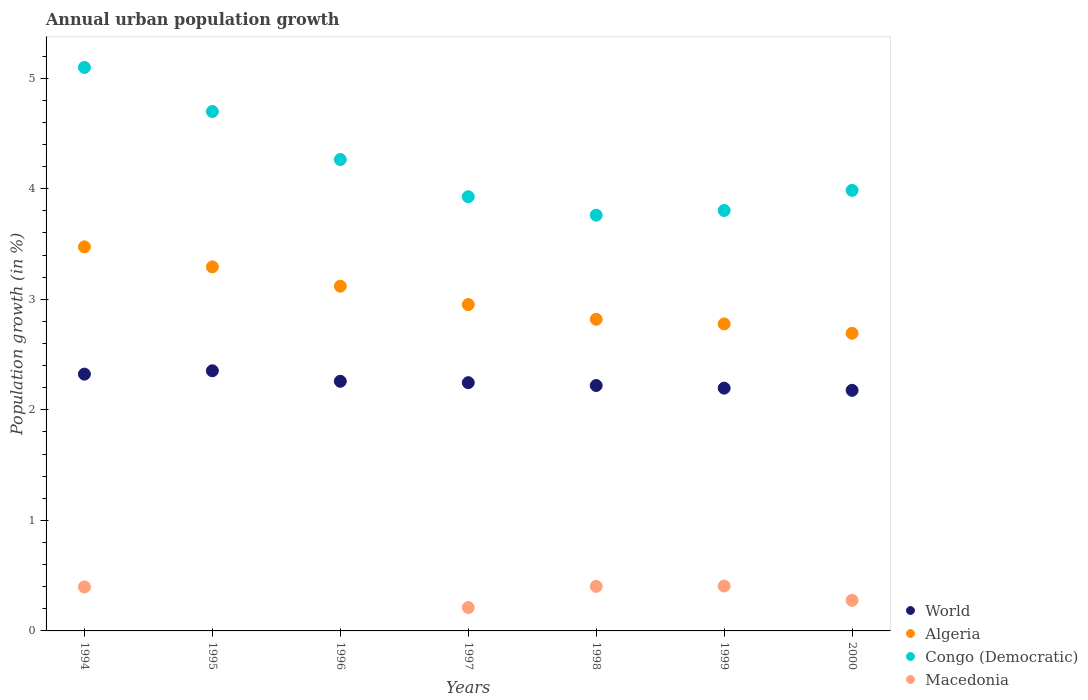How many different coloured dotlines are there?
Ensure brevity in your answer.  4. Is the number of dotlines equal to the number of legend labels?
Keep it short and to the point. No. What is the percentage of urban population growth in Algeria in 1997?
Your response must be concise. 2.95. Across all years, what is the maximum percentage of urban population growth in World?
Your answer should be very brief. 2.35. Across all years, what is the minimum percentage of urban population growth in World?
Ensure brevity in your answer.  2.18. What is the total percentage of urban population growth in Algeria in the graph?
Your answer should be compact. 21.13. What is the difference between the percentage of urban population growth in World in 1997 and that in 1998?
Your answer should be very brief. 0.03. What is the difference between the percentage of urban population growth in World in 1998 and the percentage of urban population growth in Macedonia in 1996?
Your response must be concise. 2.22. What is the average percentage of urban population growth in Congo (Democratic) per year?
Ensure brevity in your answer.  4.22. In the year 1998, what is the difference between the percentage of urban population growth in Congo (Democratic) and percentage of urban population growth in Macedonia?
Offer a very short reply. 3.36. What is the ratio of the percentage of urban population growth in World in 1996 to that in 1997?
Make the answer very short. 1.01. Is the percentage of urban population growth in Algeria in 1996 less than that in 1997?
Your answer should be very brief. No. What is the difference between the highest and the second highest percentage of urban population growth in World?
Offer a terse response. 0.03. What is the difference between the highest and the lowest percentage of urban population growth in Algeria?
Provide a succinct answer. 0.78. Is the sum of the percentage of urban population growth in World in 1996 and 2000 greater than the maximum percentage of urban population growth in Congo (Democratic) across all years?
Make the answer very short. No. Is it the case that in every year, the sum of the percentage of urban population growth in Congo (Democratic) and percentage of urban population growth in Macedonia  is greater than the sum of percentage of urban population growth in World and percentage of urban population growth in Algeria?
Your response must be concise. Yes. How many years are there in the graph?
Offer a terse response. 7. Are the values on the major ticks of Y-axis written in scientific E-notation?
Your answer should be compact. No. What is the title of the graph?
Keep it short and to the point. Annual urban population growth. Does "Rwanda" appear as one of the legend labels in the graph?
Make the answer very short. No. What is the label or title of the Y-axis?
Provide a succinct answer. Population growth (in %). What is the Population growth (in %) of World in 1994?
Make the answer very short. 2.32. What is the Population growth (in %) of Algeria in 1994?
Your answer should be compact. 3.47. What is the Population growth (in %) in Congo (Democratic) in 1994?
Offer a very short reply. 5.1. What is the Population growth (in %) in Macedonia in 1994?
Keep it short and to the point. 0.4. What is the Population growth (in %) of World in 1995?
Offer a very short reply. 2.35. What is the Population growth (in %) of Algeria in 1995?
Offer a terse response. 3.29. What is the Population growth (in %) in Congo (Democratic) in 1995?
Offer a terse response. 4.7. What is the Population growth (in %) of Macedonia in 1995?
Provide a short and direct response. 0. What is the Population growth (in %) in World in 1996?
Provide a succinct answer. 2.26. What is the Population growth (in %) in Algeria in 1996?
Your response must be concise. 3.12. What is the Population growth (in %) of Congo (Democratic) in 1996?
Give a very brief answer. 4.26. What is the Population growth (in %) in World in 1997?
Keep it short and to the point. 2.25. What is the Population growth (in %) in Algeria in 1997?
Make the answer very short. 2.95. What is the Population growth (in %) in Congo (Democratic) in 1997?
Your answer should be very brief. 3.93. What is the Population growth (in %) of Macedonia in 1997?
Offer a very short reply. 0.21. What is the Population growth (in %) in World in 1998?
Ensure brevity in your answer.  2.22. What is the Population growth (in %) in Algeria in 1998?
Keep it short and to the point. 2.82. What is the Population growth (in %) in Congo (Democratic) in 1998?
Offer a very short reply. 3.76. What is the Population growth (in %) of Macedonia in 1998?
Your response must be concise. 0.4. What is the Population growth (in %) in World in 1999?
Keep it short and to the point. 2.2. What is the Population growth (in %) in Algeria in 1999?
Your answer should be very brief. 2.78. What is the Population growth (in %) of Congo (Democratic) in 1999?
Offer a terse response. 3.8. What is the Population growth (in %) of Macedonia in 1999?
Your answer should be compact. 0.41. What is the Population growth (in %) of World in 2000?
Keep it short and to the point. 2.18. What is the Population growth (in %) of Algeria in 2000?
Offer a very short reply. 2.69. What is the Population growth (in %) in Congo (Democratic) in 2000?
Your answer should be very brief. 3.99. What is the Population growth (in %) of Macedonia in 2000?
Make the answer very short. 0.28. Across all years, what is the maximum Population growth (in %) of World?
Keep it short and to the point. 2.35. Across all years, what is the maximum Population growth (in %) in Algeria?
Give a very brief answer. 3.47. Across all years, what is the maximum Population growth (in %) in Congo (Democratic)?
Offer a terse response. 5.1. Across all years, what is the maximum Population growth (in %) of Macedonia?
Offer a terse response. 0.41. Across all years, what is the minimum Population growth (in %) in World?
Provide a succinct answer. 2.18. Across all years, what is the minimum Population growth (in %) in Algeria?
Your answer should be very brief. 2.69. Across all years, what is the minimum Population growth (in %) in Congo (Democratic)?
Make the answer very short. 3.76. Across all years, what is the minimum Population growth (in %) in Macedonia?
Provide a short and direct response. 0. What is the total Population growth (in %) in World in the graph?
Your response must be concise. 15.77. What is the total Population growth (in %) in Algeria in the graph?
Offer a terse response. 21.13. What is the total Population growth (in %) in Congo (Democratic) in the graph?
Keep it short and to the point. 29.54. What is the total Population growth (in %) in Macedonia in the graph?
Your response must be concise. 1.69. What is the difference between the Population growth (in %) in World in 1994 and that in 1995?
Give a very brief answer. -0.03. What is the difference between the Population growth (in %) in Algeria in 1994 and that in 1995?
Your answer should be very brief. 0.18. What is the difference between the Population growth (in %) in Congo (Democratic) in 1994 and that in 1995?
Your answer should be very brief. 0.4. What is the difference between the Population growth (in %) of World in 1994 and that in 1996?
Your answer should be very brief. 0.06. What is the difference between the Population growth (in %) in Algeria in 1994 and that in 1996?
Your response must be concise. 0.36. What is the difference between the Population growth (in %) of Congo (Democratic) in 1994 and that in 1996?
Keep it short and to the point. 0.83. What is the difference between the Population growth (in %) in World in 1994 and that in 1997?
Your answer should be compact. 0.08. What is the difference between the Population growth (in %) in Algeria in 1994 and that in 1997?
Make the answer very short. 0.52. What is the difference between the Population growth (in %) in Congo (Democratic) in 1994 and that in 1997?
Your response must be concise. 1.17. What is the difference between the Population growth (in %) in Macedonia in 1994 and that in 1997?
Make the answer very short. 0.19. What is the difference between the Population growth (in %) of World in 1994 and that in 1998?
Offer a terse response. 0.1. What is the difference between the Population growth (in %) of Algeria in 1994 and that in 1998?
Your answer should be compact. 0.66. What is the difference between the Population growth (in %) in Congo (Democratic) in 1994 and that in 1998?
Offer a very short reply. 1.34. What is the difference between the Population growth (in %) of Macedonia in 1994 and that in 1998?
Keep it short and to the point. -0.01. What is the difference between the Population growth (in %) of World in 1994 and that in 1999?
Make the answer very short. 0.13. What is the difference between the Population growth (in %) in Algeria in 1994 and that in 1999?
Provide a succinct answer. 0.7. What is the difference between the Population growth (in %) of Congo (Democratic) in 1994 and that in 1999?
Your response must be concise. 1.29. What is the difference between the Population growth (in %) in Macedonia in 1994 and that in 1999?
Your response must be concise. -0.01. What is the difference between the Population growth (in %) in World in 1994 and that in 2000?
Offer a terse response. 0.15. What is the difference between the Population growth (in %) in Algeria in 1994 and that in 2000?
Provide a succinct answer. 0.78. What is the difference between the Population growth (in %) in Congo (Democratic) in 1994 and that in 2000?
Your answer should be compact. 1.11. What is the difference between the Population growth (in %) of Macedonia in 1994 and that in 2000?
Offer a very short reply. 0.12. What is the difference between the Population growth (in %) in World in 1995 and that in 1996?
Offer a very short reply. 0.09. What is the difference between the Population growth (in %) of Algeria in 1995 and that in 1996?
Offer a very short reply. 0.17. What is the difference between the Population growth (in %) of Congo (Democratic) in 1995 and that in 1996?
Make the answer very short. 0.43. What is the difference between the Population growth (in %) in World in 1995 and that in 1997?
Provide a short and direct response. 0.11. What is the difference between the Population growth (in %) of Algeria in 1995 and that in 1997?
Offer a terse response. 0.34. What is the difference between the Population growth (in %) in Congo (Democratic) in 1995 and that in 1997?
Provide a succinct answer. 0.77. What is the difference between the Population growth (in %) in World in 1995 and that in 1998?
Keep it short and to the point. 0.13. What is the difference between the Population growth (in %) of Algeria in 1995 and that in 1998?
Your answer should be compact. 0.47. What is the difference between the Population growth (in %) of Congo (Democratic) in 1995 and that in 1998?
Keep it short and to the point. 0.94. What is the difference between the Population growth (in %) of World in 1995 and that in 1999?
Provide a short and direct response. 0.16. What is the difference between the Population growth (in %) in Algeria in 1995 and that in 1999?
Your answer should be compact. 0.52. What is the difference between the Population growth (in %) of Congo (Democratic) in 1995 and that in 1999?
Make the answer very short. 0.9. What is the difference between the Population growth (in %) in World in 1995 and that in 2000?
Make the answer very short. 0.18. What is the difference between the Population growth (in %) of Algeria in 1995 and that in 2000?
Make the answer very short. 0.6. What is the difference between the Population growth (in %) in Congo (Democratic) in 1995 and that in 2000?
Your answer should be compact. 0.71. What is the difference between the Population growth (in %) in World in 1996 and that in 1997?
Make the answer very short. 0.01. What is the difference between the Population growth (in %) of Algeria in 1996 and that in 1997?
Offer a terse response. 0.17. What is the difference between the Population growth (in %) of Congo (Democratic) in 1996 and that in 1997?
Your answer should be very brief. 0.34. What is the difference between the Population growth (in %) of World in 1996 and that in 1998?
Make the answer very short. 0.04. What is the difference between the Population growth (in %) in Algeria in 1996 and that in 1998?
Keep it short and to the point. 0.3. What is the difference between the Population growth (in %) in Congo (Democratic) in 1996 and that in 1998?
Your answer should be very brief. 0.5. What is the difference between the Population growth (in %) of World in 1996 and that in 1999?
Ensure brevity in your answer.  0.06. What is the difference between the Population growth (in %) of Algeria in 1996 and that in 1999?
Your answer should be very brief. 0.34. What is the difference between the Population growth (in %) in Congo (Democratic) in 1996 and that in 1999?
Keep it short and to the point. 0.46. What is the difference between the Population growth (in %) of World in 1996 and that in 2000?
Make the answer very short. 0.08. What is the difference between the Population growth (in %) of Algeria in 1996 and that in 2000?
Give a very brief answer. 0.43. What is the difference between the Population growth (in %) in Congo (Democratic) in 1996 and that in 2000?
Offer a terse response. 0.28. What is the difference between the Population growth (in %) of World in 1997 and that in 1998?
Offer a very short reply. 0.03. What is the difference between the Population growth (in %) of Algeria in 1997 and that in 1998?
Ensure brevity in your answer.  0.13. What is the difference between the Population growth (in %) of Congo (Democratic) in 1997 and that in 1998?
Keep it short and to the point. 0.17. What is the difference between the Population growth (in %) in Macedonia in 1997 and that in 1998?
Give a very brief answer. -0.19. What is the difference between the Population growth (in %) in World in 1997 and that in 1999?
Keep it short and to the point. 0.05. What is the difference between the Population growth (in %) of Algeria in 1997 and that in 1999?
Keep it short and to the point. 0.17. What is the difference between the Population growth (in %) of Congo (Democratic) in 1997 and that in 1999?
Offer a terse response. 0.12. What is the difference between the Population growth (in %) in Macedonia in 1997 and that in 1999?
Your answer should be compact. -0.19. What is the difference between the Population growth (in %) in World in 1997 and that in 2000?
Keep it short and to the point. 0.07. What is the difference between the Population growth (in %) of Algeria in 1997 and that in 2000?
Make the answer very short. 0.26. What is the difference between the Population growth (in %) of Congo (Democratic) in 1997 and that in 2000?
Your response must be concise. -0.06. What is the difference between the Population growth (in %) of Macedonia in 1997 and that in 2000?
Your response must be concise. -0.06. What is the difference between the Population growth (in %) in World in 1998 and that in 1999?
Your response must be concise. 0.02. What is the difference between the Population growth (in %) of Algeria in 1998 and that in 1999?
Ensure brevity in your answer.  0.04. What is the difference between the Population growth (in %) of Congo (Democratic) in 1998 and that in 1999?
Give a very brief answer. -0.04. What is the difference between the Population growth (in %) of Macedonia in 1998 and that in 1999?
Offer a very short reply. -0. What is the difference between the Population growth (in %) of World in 1998 and that in 2000?
Give a very brief answer. 0.04. What is the difference between the Population growth (in %) of Algeria in 1998 and that in 2000?
Provide a short and direct response. 0.13. What is the difference between the Population growth (in %) in Congo (Democratic) in 1998 and that in 2000?
Your answer should be compact. -0.22. What is the difference between the Population growth (in %) in Macedonia in 1998 and that in 2000?
Your answer should be very brief. 0.13. What is the difference between the Population growth (in %) of World in 1999 and that in 2000?
Provide a succinct answer. 0.02. What is the difference between the Population growth (in %) of Algeria in 1999 and that in 2000?
Your answer should be very brief. 0.09. What is the difference between the Population growth (in %) in Congo (Democratic) in 1999 and that in 2000?
Provide a succinct answer. -0.18. What is the difference between the Population growth (in %) of Macedonia in 1999 and that in 2000?
Offer a terse response. 0.13. What is the difference between the Population growth (in %) in World in 1994 and the Population growth (in %) in Algeria in 1995?
Provide a short and direct response. -0.97. What is the difference between the Population growth (in %) of World in 1994 and the Population growth (in %) of Congo (Democratic) in 1995?
Your answer should be compact. -2.38. What is the difference between the Population growth (in %) of Algeria in 1994 and the Population growth (in %) of Congo (Democratic) in 1995?
Your answer should be compact. -1.22. What is the difference between the Population growth (in %) in World in 1994 and the Population growth (in %) in Algeria in 1996?
Your answer should be compact. -0.8. What is the difference between the Population growth (in %) in World in 1994 and the Population growth (in %) in Congo (Democratic) in 1996?
Your answer should be compact. -1.94. What is the difference between the Population growth (in %) of Algeria in 1994 and the Population growth (in %) of Congo (Democratic) in 1996?
Offer a terse response. -0.79. What is the difference between the Population growth (in %) in World in 1994 and the Population growth (in %) in Algeria in 1997?
Ensure brevity in your answer.  -0.63. What is the difference between the Population growth (in %) of World in 1994 and the Population growth (in %) of Congo (Democratic) in 1997?
Provide a succinct answer. -1.6. What is the difference between the Population growth (in %) of World in 1994 and the Population growth (in %) of Macedonia in 1997?
Your answer should be very brief. 2.11. What is the difference between the Population growth (in %) of Algeria in 1994 and the Population growth (in %) of Congo (Democratic) in 1997?
Provide a short and direct response. -0.45. What is the difference between the Population growth (in %) of Algeria in 1994 and the Population growth (in %) of Macedonia in 1997?
Offer a very short reply. 3.26. What is the difference between the Population growth (in %) in Congo (Democratic) in 1994 and the Population growth (in %) in Macedonia in 1997?
Your answer should be very brief. 4.89. What is the difference between the Population growth (in %) in World in 1994 and the Population growth (in %) in Algeria in 1998?
Provide a short and direct response. -0.5. What is the difference between the Population growth (in %) of World in 1994 and the Population growth (in %) of Congo (Democratic) in 1998?
Your answer should be compact. -1.44. What is the difference between the Population growth (in %) in World in 1994 and the Population growth (in %) in Macedonia in 1998?
Give a very brief answer. 1.92. What is the difference between the Population growth (in %) in Algeria in 1994 and the Population growth (in %) in Congo (Democratic) in 1998?
Provide a succinct answer. -0.29. What is the difference between the Population growth (in %) in Algeria in 1994 and the Population growth (in %) in Macedonia in 1998?
Your answer should be compact. 3.07. What is the difference between the Population growth (in %) in Congo (Democratic) in 1994 and the Population growth (in %) in Macedonia in 1998?
Ensure brevity in your answer.  4.69. What is the difference between the Population growth (in %) in World in 1994 and the Population growth (in %) in Algeria in 1999?
Keep it short and to the point. -0.45. What is the difference between the Population growth (in %) in World in 1994 and the Population growth (in %) in Congo (Democratic) in 1999?
Your response must be concise. -1.48. What is the difference between the Population growth (in %) in World in 1994 and the Population growth (in %) in Macedonia in 1999?
Offer a very short reply. 1.92. What is the difference between the Population growth (in %) in Algeria in 1994 and the Population growth (in %) in Congo (Democratic) in 1999?
Your answer should be very brief. -0.33. What is the difference between the Population growth (in %) of Algeria in 1994 and the Population growth (in %) of Macedonia in 1999?
Offer a terse response. 3.07. What is the difference between the Population growth (in %) in Congo (Democratic) in 1994 and the Population growth (in %) in Macedonia in 1999?
Give a very brief answer. 4.69. What is the difference between the Population growth (in %) of World in 1994 and the Population growth (in %) of Algeria in 2000?
Your answer should be compact. -0.37. What is the difference between the Population growth (in %) in World in 1994 and the Population growth (in %) in Congo (Democratic) in 2000?
Offer a very short reply. -1.66. What is the difference between the Population growth (in %) of World in 1994 and the Population growth (in %) of Macedonia in 2000?
Your answer should be compact. 2.05. What is the difference between the Population growth (in %) in Algeria in 1994 and the Population growth (in %) in Congo (Democratic) in 2000?
Offer a very short reply. -0.51. What is the difference between the Population growth (in %) in Algeria in 1994 and the Population growth (in %) in Macedonia in 2000?
Your response must be concise. 3.2. What is the difference between the Population growth (in %) in Congo (Democratic) in 1994 and the Population growth (in %) in Macedonia in 2000?
Ensure brevity in your answer.  4.82. What is the difference between the Population growth (in %) of World in 1995 and the Population growth (in %) of Algeria in 1996?
Make the answer very short. -0.77. What is the difference between the Population growth (in %) in World in 1995 and the Population growth (in %) in Congo (Democratic) in 1996?
Offer a terse response. -1.91. What is the difference between the Population growth (in %) of Algeria in 1995 and the Population growth (in %) of Congo (Democratic) in 1996?
Provide a succinct answer. -0.97. What is the difference between the Population growth (in %) of World in 1995 and the Population growth (in %) of Algeria in 1997?
Offer a terse response. -0.6. What is the difference between the Population growth (in %) in World in 1995 and the Population growth (in %) in Congo (Democratic) in 1997?
Provide a short and direct response. -1.57. What is the difference between the Population growth (in %) of World in 1995 and the Population growth (in %) of Macedonia in 1997?
Provide a short and direct response. 2.14. What is the difference between the Population growth (in %) in Algeria in 1995 and the Population growth (in %) in Congo (Democratic) in 1997?
Give a very brief answer. -0.64. What is the difference between the Population growth (in %) of Algeria in 1995 and the Population growth (in %) of Macedonia in 1997?
Provide a succinct answer. 3.08. What is the difference between the Population growth (in %) in Congo (Democratic) in 1995 and the Population growth (in %) in Macedonia in 1997?
Your answer should be compact. 4.49. What is the difference between the Population growth (in %) of World in 1995 and the Population growth (in %) of Algeria in 1998?
Your response must be concise. -0.47. What is the difference between the Population growth (in %) in World in 1995 and the Population growth (in %) in Congo (Democratic) in 1998?
Your response must be concise. -1.41. What is the difference between the Population growth (in %) of World in 1995 and the Population growth (in %) of Macedonia in 1998?
Your answer should be very brief. 1.95. What is the difference between the Population growth (in %) of Algeria in 1995 and the Population growth (in %) of Congo (Democratic) in 1998?
Ensure brevity in your answer.  -0.47. What is the difference between the Population growth (in %) of Algeria in 1995 and the Population growth (in %) of Macedonia in 1998?
Make the answer very short. 2.89. What is the difference between the Population growth (in %) in Congo (Democratic) in 1995 and the Population growth (in %) in Macedonia in 1998?
Your answer should be very brief. 4.3. What is the difference between the Population growth (in %) of World in 1995 and the Population growth (in %) of Algeria in 1999?
Offer a very short reply. -0.42. What is the difference between the Population growth (in %) of World in 1995 and the Population growth (in %) of Congo (Democratic) in 1999?
Keep it short and to the point. -1.45. What is the difference between the Population growth (in %) of World in 1995 and the Population growth (in %) of Macedonia in 1999?
Ensure brevity in your answer.  1.95. What is the difference between the Population growth (in %) in Algeria in 1995 and the Population growth (in %) in Congo (Democratic) in 1999?
Offer a very short reply. -0.51. What is the difference between the Population growth (in %) of Algeria in 1995 and the Population growth (in %) of Macedonia in 1999?
Offer a terse response. 2.89. What is the difference between the Population growth (in %) in Congo (Democratic) in 1995 and the Population growth (in %) in Macedonia in 1999?
Provide a short and direct response. 4.29. What is the difference between the Population growth (in %) in World in 1995 and the Population growth (in %) in Algeria in 2000?
Ensure brevity in your answer.  -0.34. What is the difference between the Population growth (in %) of World in 1995 and the Population growth (in %) of Congo (Democratic) in 2000?
Your response must be concise. -1.63. What is the difference between the Population growth (in %) in World in 1995 and the Population growth (in %) in Macedonia in 2000?
Provide a succinct answer. 2.08. What is the difference between the Population growth (in %) in Algeria in 1995 and the Population growth (in %) in Congo (Democratic) in 2000?
Ensure brevity in your answer.  -0.69. What is the difference between the Population growth (in %) in Algeria in 1995 and the Population growth (in %) in Macedonia in 2000?
Give a very brief answer. 3.02. What is the difference between the Population growth (in %) in Congo (Democratic) in 1995 and the Population growth (in %) in Macedonia in 2000?
Keep it short and to the point. 4.42. What is the difference between the Population growth (in %) of World in 1996 and the Population growth (in %) of Algeria in 1997?
Your response must be concise. -0.69. What is the difference between the Population growth (in %) in World in 1996 and the Population growth (in %) in Congo (Democratic) in 1997?
Your answer should be compact. -1.67. What is the difference between the Population growth (in %) of World in 1996 and the Population growth (in %) of Macedonia in 1997?
Provide a short and direct response. 2.05. What is the difference between the Population growth (in %) in Algeria in 1996 and the Population growth (in %) in Congo (Democratic) in 1997?
Your answer should be compact. -0.81. What is the difference between the Population growth (in %) of Algeria in 1996 and the Population growth (in %) of Macedonia in 1997?
Offer a terse response. 2.91. What is the difference between the Population growth (in %) of Congo (Democratic) in 1996 and the Population growth (in %) of Macedonia in 1997?
Your answer should be very brief. 4.05. What is the difference between the Population growth (in %) of World in 1996 and the Population growth (in %) of Algeria in 1998?
Ensure brevity in your answer.  -0.56. What is the difference between the Population growth (in %) in World in 1996 and the Population growth (in %) in Congo (Democratic) in 1998?
Your response must be concise. -1.5. What is the difference between the Population growth (in %) in World in 1996 and the Population growth (in %) in Macedonia in 1998?
Your response must be concise. 1.86. What is the difference between the Population growth (in %) in Algeria in 1996 and the Population growth (in %) in Congo (Democratic) in 1998?
Ensure brevity in your answer.  -0.64. What is the difference between the Population growth (in %) of Algeria in 1996 and the Population growth (in %) of Macedonia in 1998?
Your answer should be compact. 2.72. What is the difference between the Population growth (in %) of Congo (Democratic) in 1996 and the Population growth (in %) of Macedonia in 1998?
Keep it short and to the point. 3.86. What is the difference between the Population growth (in %) of World in 1996 and the Population growth (in %) of Algeria in 1999?
Your answer should be very brief. -0.52. What is the difference between the Population growth (in %) in World in 1996 and the Population growth (in %) in Congo (Democratic) in 1999?
Offer a terse response. -1.54. What is the difference between the Population growth (in %) in World in 1996 and the Population growth (in %) in Macedonia in 1999?
Your answer should be very brief. 1.85. What is the difference between the Population growth (in %) in Algeria in 1996 and the Population growth (in %) in Congo (Democratic) in 1999?
Your response must be concise. -0.68. What is the difference between the Population growth (in %) in Algeria in 1996 and the Population growth (in %) in Macedonia in 1999?
Your response must be concise. 2.71. What is the difference between the Population growth (in %) in Congo (Democratic) in 1996 and the Population growth (in %) in Macedonia in 1999?
Ensure brevity in your answer.  3.86. What is the difference between the Population growth (in %) of World in 1996 and the Population growth (in %) of Algeria in 2000?
Your response must be concise. -0.43. What is the difference between the Population growth (in %) in World in 1996 and the Population growth (in %) in Congo (Democratic) in 2000?
Your answer should be very brief. -1.73. What is the difference between the Population growth (in %) of World in 1996 and the Population growth (in %) of Macedonia in 2000?
Provide a short and direct response. 1.98. What is the difference between the Population growth (in %) in Algeria in 1996 and the Population growth (in %) in Congo (Democratic) in 2000?
Provide a short and direct response. -0.87. What is the difference between the Population growth (in %) in Algeria in 1996 and the Population growth (in %) in Macedonia in 2000?
Offer a very short reply. 2.84. What is the difference between the Population growth (in %) of Congo (Democratic) in 1996 and the Population growth (in %) of Macedonia in 2000?
Your answer should be very brief. 3.99. What is the difference between the Population growth (in %) of World in 1997 and the Population growth (in %) of Algeria in 1998?
Provide a short and direct response. -0.57. What is the difference between the Population growth (in %) of World in 1997 and the Population growth (in %) of Congo (Democratic) in 1998?
Provide a short and direct response. -1.52. What is the difference between the Population growth (in %) in World in 1997 and the Population growth (in %) in Macedonia in 1998?
Your answer should be compact. 1.84. What is the difference between the Population growth (in %) in Algeria in 1997 and the Population growth (in %) in Congo (Democratic) in 1998?
Keep it short and to the point. -0.81. What is the difference between the Population growth (in %) in Algeria in 1997 and the Population growth (in %) in Macedonia in 1998?
Provide a short and direct response. 2.55. What is the difference between the Population growth (in %) of Congo (Democratic) in 1997 and the Population growth (in %) of Macedonia in 1998?
Provide a succinct answer. 3.52. What is the difference between the Population growth (in %) in World in 1997 and the Population growth (in %) in Algeria in 1999?
Provide a short and direct response. -0.53. What is the difference between the Population growth (in %) of World in 1997 and the Population growth (in %) of Congo (Democratic) in 1999?
Offer a very short reply. -1.56. What is the difference between the Population growth (in %) of World in 1997 and the Population growth (in %) of Macedonia in 1999?
Offer a very short reply. 1.84. What is the difference between the Population growth (in %) in Algeria in 1997 and the Population growth (in %) in Congo (Democratic) in 1999?
Keep it short and to the point. -0.85. What is the difference between the Population growth (in %) in Algeria in 1997 and the Population growth (in %) in Macedonia in 1999?
Offer a very short reply. 2.55. What is the difference between the Population growth (in %) of Congo (Democratic) in 1997 and the Population growth (in %) of Macedonia in 1999?
Your response must be concise. 3.52. What is the difference between the Population growth (in %) of World in 1997 and the Population growth (in %) of Algeria in 2000?
Provide a short and direct response. -0.45. What is the difference between the Population growth (in %) of World in 1997 and the Population growth (in %) of Congo (Democratic) in 2000?
Give a very brief answer. -1.74. What is the difference between the Population growth (in %) of World in 1997 and the Population growth (in %) of Macedonia in 2000?
Keep it short and to the point. 1.97. What is the difference between the Population growth (in %) of Algeria in 1997 and the Population growth (in %) of Congo (Democratic) in 2000?
Give a very brief answer. -1.03. What is the difference between the Population growth (in %) in Algeria in 1997 and the Population growth (in %) in Macedonia in 2000?
Give a very brief answer. 2.68. What is the difference between the Population growth (in %) in Congo (Democratic) in 1997 and the Population growth (in %) in Macedonia in 2000?
Your response must be concise. 3.65. What is the difference between the Population growth (in %) of World in 1998 and the Population growth (in %) of Algeria in 1999?
Ensure brevity in your answer.  -0.56. What is the difference between the Population growth (in %) of World in 1998 and the Population growth (in %) of Congo (Democratic) in 1999?
Offer a very short reply. -1.58. What is the difference between the Population growth (in %) of World in 1998 and the Population growth (in %) of Macedonia in 1999?
Your answer should be very brief. 1.81. What is the difference between the Population growth (in %) of Algeria in 1998 and the Population growth (in %) of Congo (Democratic) in 1999?
Keep it short and to the point. -0.98. What is the difference between the Population growth (in %) of Algeria in 1998 and the Population growth (in %) of Macedonia in 1999?
Ensure brevity in your answer.  2.41. What is the difference between the Population growth (in %) in Congo (Democratic) in 1998 and the Population growth (in %) in Macedonia in 1999?
Provide a short and direct response. 3.36. What is the difference between the Population growth (in %) of World in 1998 and the Population growth (in %) of Algeria in 2000?
Your response must be concise. -0.47. What is the difference between the Population growth (in %) of World in 1998 and the Population growth (in %) of Congo (Democratic) in 2000?
Ensure brevity in your answer.  -1.77. What is the difference between the Population growth (in %) of World in 1998 and the Population growth (in %) of Macedonia in 2000?
Your answer should be very brief. 1.94. What is the difference between the Population growth (in %) in Algeria in 1998 and the Population growth (in %) in Congo (Democratic) in 2000?
Make the answer very short. -1.17. What is the difference between the Population growth (in %) in Algeria in 1998 and the Population growth (in %) in Macedonia in 2000?
Your response must be concise. 2.54. What is the difference between the Population growth (in %) of Congo (Democratic) in 1998 and the Population growth (in %) of Macedonia in 2000?
Provide a short and direct response. 3.48. What is the difference between the Population growth (in %) of World in 1999 and the Population growth (in %) of Algeria in 2000?
Ensure brevity in your answer.  -0.5. What is the difference between the Population growth (in %) in World in 1999 and the Population growth (in %) in Congo (Democratic) in 2000?
Offer a very short reply. -1.79. What is the difference between the Population growth (in %) in World in 1999 and the Population growth (in %) in Macedonia in 2000?
Provide a short and direct response. 1.92. What is the difference between the Population growth (in %) of Algeria in 1999 and the Population growth (in %) of Congo (Democratic) in 2000?
Provide a succinct answer. -1.21. What is the difference between the Population growth (in %) in Algeria in 1999 and the Population growth (in %) in Macedonia in 2000?
Give a very brief answer. 2.5. What is the difference between the Population growth (in %) in Congo (Democratic) in 1999 and the Population growth (in %) in Macedonia in 2000?
Offer a terse response. 3.53. What is the average Population growth (in %) in World per year?
Ensure brevity in your answer.  2.25. What is the average Population growth (in %) in Algeria per year?
Provide a short and direct response. 3.02. What is the average Population growth (in %) of Congo (Democratic) per year?
Offer a terse response. 4.22. What is the average Population growth (in %) in Macedonia per year?
Give a very brief answer. 0.24. In the year 1994, what is the difference between the Population growth (in %) of World and Population growth (in %) of Algeria?
Your answer should be very brief. -1.15. In the year 1994, what is the difference between the Population growth (in %) in World and Population growth (in %) in Congo (Democratic)?
Provide a succinct answer. -2.77. In the year 1994, what is the difference between the Population growth (in %) of World and Population growth (in %) of Macedonia?
Keep it short and to the point. 1.93. In the year 1994, what is the difference between the Population growth (in %) in Algeria and Population growth (in %) in Congo (Democratic)?
Make the answer very short. -1.62. In the year 1994, what is the difference between the Population growth (in %) of Algeria and Population growth (in %) of Macedonia?
Give a very brief answer. 3.08. In the year 1994, what is the difference between the Population growth (in %) of Congo (Democratic) and Population growth (in %) of Macedonia?
Your answer should be very brief. 4.7. In the year 1995, what is the difference between the Population growth (in %) in World and Population growth (in %) in Algeria?
Your answer should be very brief. -0.94. In the year 1995, what is the difference between the Population growth (in %) of World and Population growth (in %) of Congo (Democratic)?
Your answer should be compact. -2.35. In the year 1995, what is the difference between the Population growth (in %) in Algeria and Population growth (in %) in Congo (Democratic)?
Give a very brief answer. -1.41. In the year 1996, what is the difference between the Population growth (in %) in World and Population growth (in %) in Algeria?
Your answer should be compact. -0.86. In the year 1996, what is the difference between the Population growth (in %) in World and Population growth (in %) in Congo (Democratic)?
Offer a very short reply. -2.01. In the year 1996, what is the difference between the Population growth (in %) in Algeria and Population growth (in %) in Congo (Democratic)?
Offer a terse response. -1.15. In the year 1997, what is the difference between the Population growth (in %) of World and Population growth (in %) of Algeria?
Offer a terse response. -0.71. In the year 1997, what is the difference between the Population growth (in %) of World and Population growth (in %) of Congo (Democratic)?
Your answer should be very brief. -1.68. In the year 1997, what is the difference between the Population growth (in %) in World and Population growth (in %) in Macedonia?
Your answer should be compact. 2.03. In the year 1997, what is the difference between the Population growth (in %) of Algeria and Population growth (in %) of Congo (Democratic)?
Provide a succinct answer. -0.98. In the year 1997, what is the difference between the Population growth (in %) of Algeria and Population growth (in %) of Macedonia?
Provide a succinct answer. 2.74. In the year 1997, what is the difference between the Population growth (in %) in Congo (Democratic) and Population growth (in %) in Macedonia?
Your answer should be very brief. 3.72. In the year 1998, what is the difference between the Population growth (in %) in World and Population growth (in %) in Algeria?
Provide a succinct answer. -0.6. In the year 1998, what is the difference between the Population growth (in %) in World and Population growth (in %) in Congo (Democratic)?
Ensure brevity in your answer.  -1.54. In the year 1998, what is the difference between the Population growth (in %) in World and Population growth (in %) in Macedonia?
Offer a very short reply. 1.82. In the year 1998, what is the difference between the Population growth (in %) in Algeria and Population growth (in %) in Congo (Democratic)?
Provide a short and direct response. -0.94. In the year 1998, what is the difference between the Population growth (in %) in Algeria and Population growth (in %) in Macedonia?
Offer a terse response. 2.42. In the year 1998, what is the difference between the Population growth (in %) in Congo (Democratic) and Population growth (in %) in Macedonia?
Your answer should be compact. 3.36. In the year 1999, what is the difference between the Population growth (in %) in World and Population growth (in %) in Algeria?
Give a very brief answer. -0.58. In the year 1999, what is the difference between the Population growth (in %) in World and Population growth (in %) in Congo (Democratic)?
Your response must be concise. -1.61. In the year 1999, what is the difference between the Population growth (in %) of World and Population growth (in %) of Macedonia?
Give a very brief answer. 1.79. In the year 1999, what is the difference between the Population growth (in %) in Algeria and Population growth (in %) in Congo (Democratic)?
Give a very brief answer. -1.03. In the year 1999, what is the difference between the Population growth (in %) of Algeria and Population growth (in %) of Macedonia?
Ensure brevity in your answer.  2.37. In the year 1999, what is the difference between the Population growth (in %) of Congo (Democratic) and Population growth (in %) of Macedonia?
Provide a succinct answer. 3.4. In the year 2000, what is the difference between the Population growth (in %) of World and Population growth (in %) of Algeria?
Your answer should be very brief. -0.52. In the year 2000, what is the difference between the Population growth (in %) in World and Population growth (in %) in Congo (Democratic)?
Provide a short and direct response. -1.81. In the year 2000, what is the difference between the Population growth (in %) of World and Population growth (in %) of Macedonia?
Give a very brief answer. 1.9. In the year 2000, what is the difference between the Population growth (in %) of Algeria and Population growth (in %) of Congo (Democratic)?
Your response must be concise. -1.29. In the year 2000, what is the difference between the Population growth (in %) of Algeria and Population growth (in %) of Macedonia?
Ensure brevity in your answer.  2.42. In the year 2000, what is the difference between the Population growth (in %) of Congo (Democratic) and Population growth (in %) of Macedonia?
Ensure brevity in your answer.  3.71. What is the ratio of the Population growth (in %) of World in 1994 to that in 1995?
Provide a short and direct response. 0.99. What is the ratio of the Population growth (in %) of Algeria in 1994 to that in 1995?
Offer a very short reply. 1.06. What is the ratio of the Population growth (in %) in Congo (Democratic) in 1994 to that in 1995?
Your response must be concise. 1.08. What is the ratio of the Population growth (in %) in World in 1994 to that in 1996?
Offer a terse response. 1.03. What is the ratio of the Population growth (in %) of Algeria in 1994 to that in 1996?
Your answer should be very brief. 1.11. What is the ratio of the Population growth (in %) of Congo (Democratic) in 1994 to that in 1996?
Ensure brevity in your answer.  1.2. What is the ratio of the Population growth (in %) of World in 1994 to that in 1997?
Make the answer very short. 1.03. What is the ratio of the Population growth (in %) in Algeria in 1994 to that in 1997?
Give a very brief answer. 1.18. What is the ratio of the Population growth (in %) of Congo (Democratic) in 1994 to that in 1997?
Offer a very short reply. 1.3. What is the ratio of the Population growth (in %) of Macedonia in 1994 to that in 1997?
Make the answer very short. 1.88. What is the ratio of the Population growth (in %) of World in 1994 to that in 1998?
Ensure brevity in your answer.  1.05. What is the ratio of the Population growth (in %) in Algeria in 1994 to that in 1998?
Your answer should be very brief. 1.23. What is the ratio of the Population growth (in %) in Congo (Democratic) in 1994 to that in 1998?
Ensure brevity in your answer.  1.36. What is the ratio of the Population growth (in %) of Macedonia in 1994 to that in 1998?
Make the answer very short. 0.99. What is the ratio of the Population growth (in %) in World in 1994 to that in 1999?
Keep it short and to the point. 1.06. What is the ratio of the Population growth (in %) in Algeria in 1994 to that in 1999?
Give a very brief answer. 1.25. What is the ratio of the Population growth (in %) in Congo (Democratic) in 1994 to that in 1999?
Your answer should be compact. 1.34. What is the ratio of the Population growth (in %) of Macedonia in 1994 to that in 1999?
Your response must be concise. 0.98. What is the ratio of the Population growth (in %) in World in 1994 to that in 2000?
Provide a short and direct response. 1.07. What is the ratio of the Population growth (in %) of Algeria in 1994 to that in 2000?
Ensure brevity in your answer.  1.29. What is the ratio of the Population growth (in %) of Congo (Democratic) in 1994 to that in 2000?
Your answer should be compact. 1.28. What is the ratio of the Population growth (in %) in Macedonia in 1994 to that in 2000?
Your answer should be compact. 1.44. What is the ratio of the Population growth (in %) in World in 1995 to that in 1996?
Make the answer very short. 1.04. What is the ratio of the Population growth (in %) in Algeria in 1995 to that in 1996?
Offer a very short reply. 1.06. What is the ratio of the Population growth (in %) of Congo (Democratic) in 1995 to that in 1996?
Give a very brief answer. 1.1. What is the ratio of the Population growth (in %) in World in 1995 to that in 1997?
Keep it short and to the point. 1.05. What is the ratio of the Population growth (in %) in Algeria in 1995 to that in 1997?
Make the answer very short. 1.12. What is the ratio of the Population growth (in %) of Congo (Democratic) in 1995 to that in 1997?
Keep it short and to the point. 1.2. What is the ratio of the Population growth (in %) of World in 1995 to that in 1998?
Ensure brevity in your answer.  1.06. What is the ratio of the Population growth (in %) of Algeria in 1995 to that in 1998?
Your answer should be very brief. 1.17. What is the ratio of the Population growth (in %) in Congo (Democratic) in 1995 to that in 1998?
Provide a succinct answer. 1.25. What is the ratio of the Population growth (in %) in World in 1995 to that in 1999?
Keep it short and to the point. 1.07. What is the ratio of the Population growth (in %) of Algeria in 1995 to that in 1999?
Give a very brief answer. 1.19. What is the ratio of the Population growth (in %) in Congo (Democratic) in 1995 to that in 1999?
Your answer should be very brief. 1.24. What is the ratio of the Population growth (in %) in World in 1995 to that in 2000?
Provide a succinct answer. 1.08. What is the ratio of the Population growth (in %) of Algeria in 1995 to that in 2000?
Your response must be concise. 1.22. What is the ratio of the Population growth (in %) in Congo (Democratic) in 1995 to that in 2000?
Your answer should be very brief. 1.18. What is the ratio of the Population growth (in %) in Algeria in 1996 to that in 1997?
Keep it short and to the point. 1.06. What is the ratio of the Population growth (in %) of Congo (Democratic) in 1996 to that in 1997?
Provide a short and direct response. 1.09. What is the ratio of the Population growth (in %) in World in 1996 to that in 1998?
Offer a very short reply. 1.02. What is the ratio of the Population growth (in %) of Algeria in 1996 to that in 1998?
Offer a very short reply. 1.11. What is the ratio of the Population growth (in %) in Congo (Democratic) in 1996 to that in 1998?
Ensure brevity in your answer.  1.13. What is the ratio of the Population growth (in %) in World in 1996 to that in 1999?
Make the answer very short. 1.03. What is the ratio of the Population growth (in %) of Algeria in 1996 to that in 1999?
Offer a very short reply. 1.12. What is the ratio of the Population growth (in %) in Congo (Democratic) in 1996 to that in 1999?
Ensure brevity in your answer.  1.12. What is the ratio of the Population growth (in %) of World in 1996 to that in 2000?
Keep it short and to the point. 1.04. What is the ratio of the Population growth (in %) of Algeria in 1996 to that in 2000?
Your answer should be very brief. 1.16. What is the ratio of the Population growth (in %) in Congo (Democratic) in 1996 to that in 2000?
Offer a terse response. 1.07. What is the ratio of the Population growth (in %) of World in 1997 to that in 1998?
Your answer should be compact. 1.01. What is the ratio of the Population growth (in %) in Algeria in 1997 to that in 1998?
Give a very brief answer. 1.05. What is the ratio of the Population growth (in %) of Congo (Democratic) in 1997 to that in 1998?
Offer a terse response. 1.04. What is the ratio of the Population growth (in %) of Macedonia in 1997 to that in 1998?
Give a very brief answer. 0.52. What is the ratio of the Population growth (in %) in World in 1997 to that in 1999?
Your answer should be very brief. 1.02. What is the ratio of the Population growth (in %) of Algeria in 1997 to that in 1999?
Offer a terse response. 1.06. What is the ratio of the Population growth (in %) in Congo (Democratic) in 1997 to that in 1999?
Offer a terse response. 1.03. What is the ratio of the Population growth (in %) of Macedonia in 1997 to that in 1999?
Provide a succinct answer. 0.52. What is the ratio of the Population growth (in %) of World in 1997 to that in 2000?
Keep it short and to the point. 1.03. What is the ratio of the Population growth (in %) in Algeria in 1997 to that in 2000?
Your answer should be very brief. 1.1. What is the ratio of the Population growth (in %) of Congo (Democratic) in 1997 to that in 2000?
Your response must be concise. 0.99. What is the ratio of the Population growth (in %) in Macedonia in 1997 to that in 2000?
Give a very brief answer. 0.77. What is the ratio of the Population growth (in %) in World in 1998 to that in 1999?
Ensure brevity in your answer.  1.01. What is the ratio of the Population growth (in %) in Congo (Democratic) in 1998 to that in 1999?
Provide a succinct answer. 0.99. What is the ratio of the Population growth (in %) of Macedonia in 1998 to that in 1999?
Your response must be concise. 0.99. What is the ratio of the Population growth (in %) in World in 1998 to that in 2000?
Provide a succinct answer. 1.02. What is the ratio of the Population growth (in %) of Algeria in 1998 to that in 2000?
Offer a terse response. 1.05. What is the ratio of the Population growth (in %) of Congo (Democratic) in 1998 to that in 2000?
Offer a terse response. 0.94. What is the ratio of the Population growth (in %) in Macedonia in 1998 to that in 2000?
Give a very brief answer. 1.46. What is the ratio of the Population growth (in %) in World in 1999 to that in 2000?
Make the answer very short. 1.01. What is the ratio of the Population growth (in %) in Algeria in 1999 to that in 2000?
Ensure brevity in your answer.  1.03. What is the ratio of the Population growth (in %) in Congo (Democratic) in 1999 to that in 2000?
Give a very brief answer. 0.95. What is the ratio of the Population growth (in %) in Macedonia in 1999 to that in 2000?
Offer a terse response. 1.47. What is the difference between the highest and the second highest Population growth (in %) in World?
Ensure brevity in your answer.  0.03. What is the difference between the highest and the second highest Population growth (in %) of Algeria?
Offer a terse response. 0.18. What is the difference between the highest and the second highest Population growth (in %) of Congo (Democratic)?
Your answer should be very brief. 0.4. What is the difference between the highest and the second highest Population growth (in %) in Macedonia?
Offer a terse response. 0. What is the difference between the highest and the lowest Population growth (in %) of World?
Give a very brief answer. 0.18. What is the difference between the highest and the lowest Population growth (in %) in Algeria?
Your answer should be very brief. 0.78. What is the difference between the highest and the lowest Population growth (in %) of Congo (Democratic)?
Keep it short and to the point. 1.34. What is the difference between the highest and the lowest Population growth (in %) in Macedonia?
Offer a terse response. 0.41. 